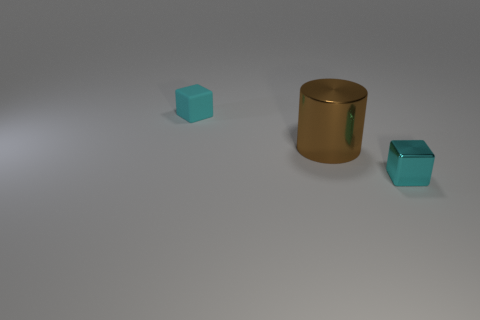Add 3 tiny cyan cubes. How many objects exist? 6 Subtract all cylinders. How many objects are left? 2 Add 3 tiny cyan objects. How many tiny cyan objects are left? 5 Add 3 matte cubes. How many matte cubes exist? 4 Subtract 0 yellow cylinders. How many objects are left? 3 Subtract all blocks. Subtract all large brown shiny cylinders. How many objects are left? 0 